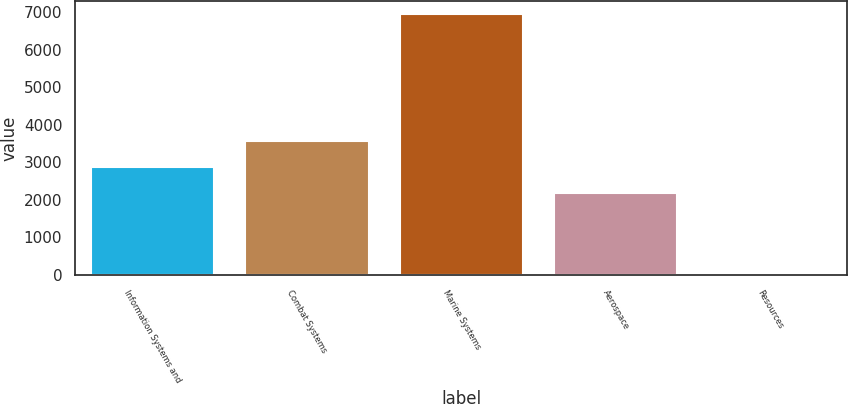<chart> <loc_0><loc_0><loc_500><loc_500><bar_chart><fcel>Information Systems and<fcel>Combat Systems<fcel>Marine Systems<fcel>Aerospace<fcel>Resources<nl><fcel>2880.5<fcel>3569<fcel>6943<fcel>2192<fcel>58<nl></chart> 